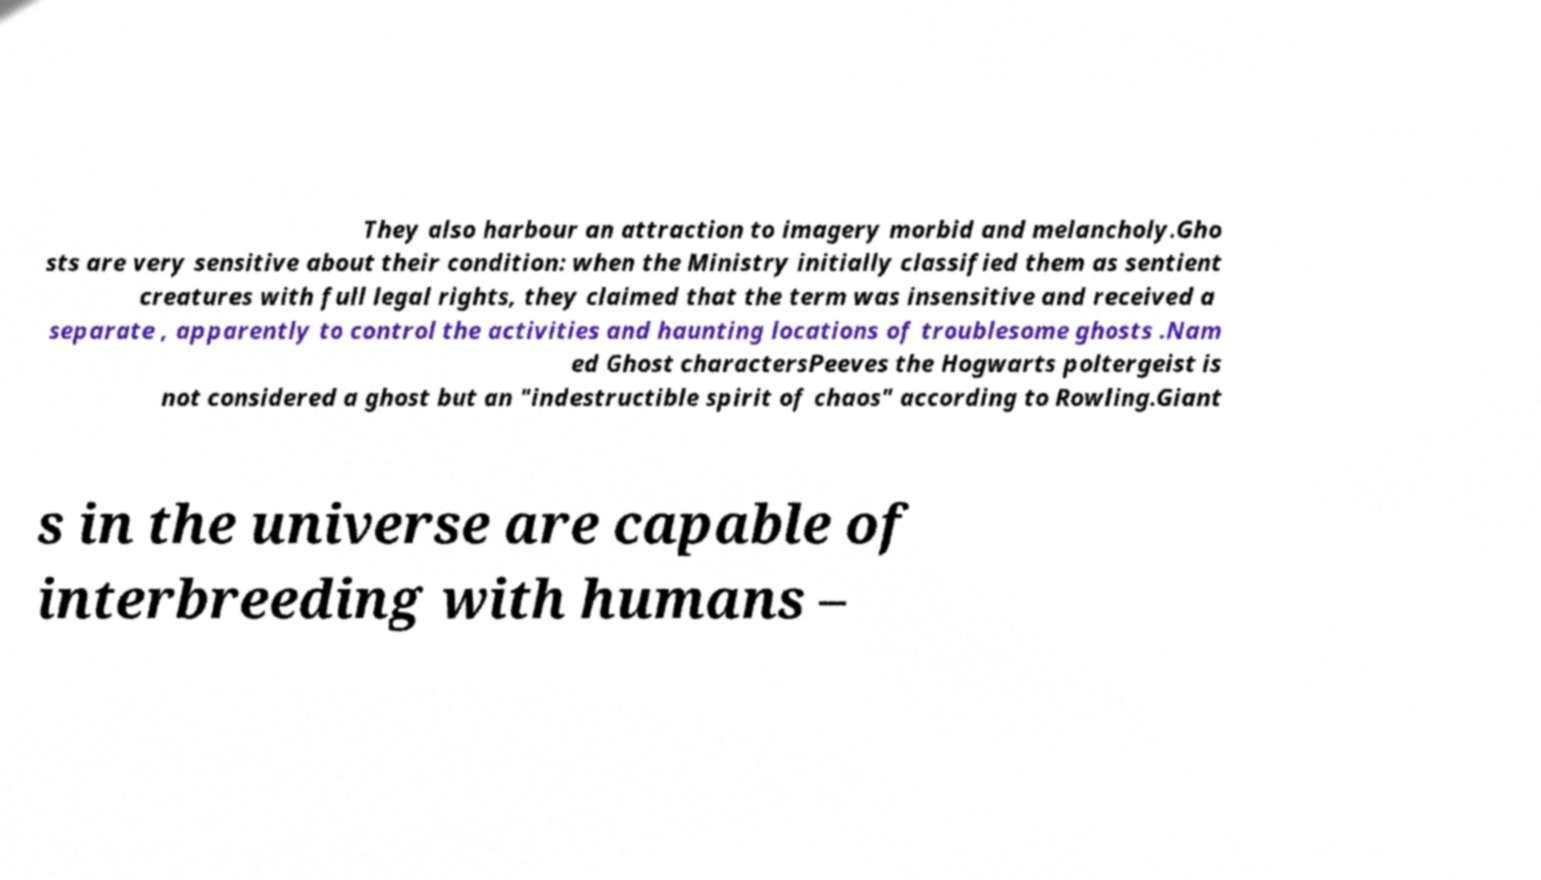Can you read and provide the text displayed in the image?This photo seems to have some interesting text. Can you extract and type it out for me? They also harbour an attraction to imagery morbid and melancholy.Gho sts are very sensitive about their condition: when the Ministry initially classified them as sentient creatures with full legal rights, they claimed that the term was insensitive and received a separate , apparently to control the activities and haunting locations of troublesome ghosts .Nam ed Ghost charactersPeeves the Hogwarts poltergeist is not considered a ghost but an "indestructible spirit of chaos" according to Rowling.Giant s in the universe are capable of interbreeding with humans – 